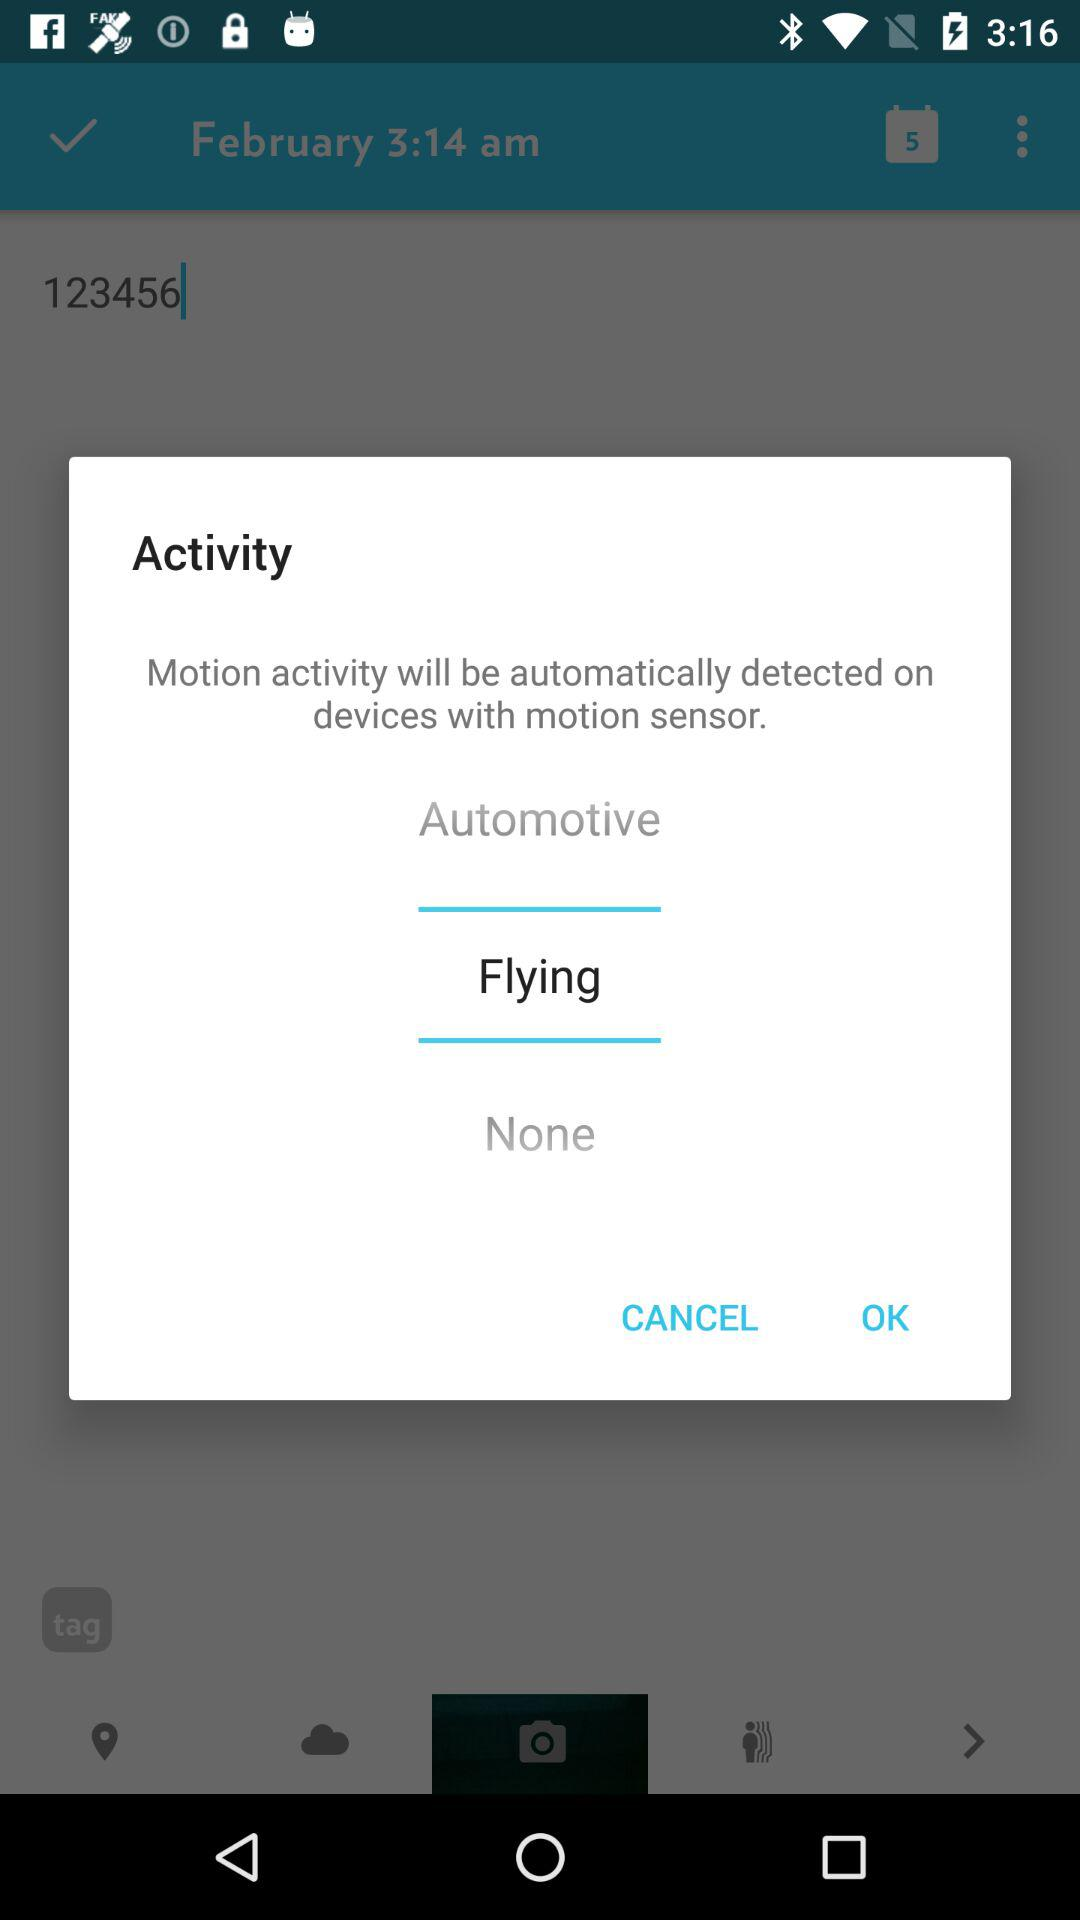What is the mentioned month? The mentioned month is February. 